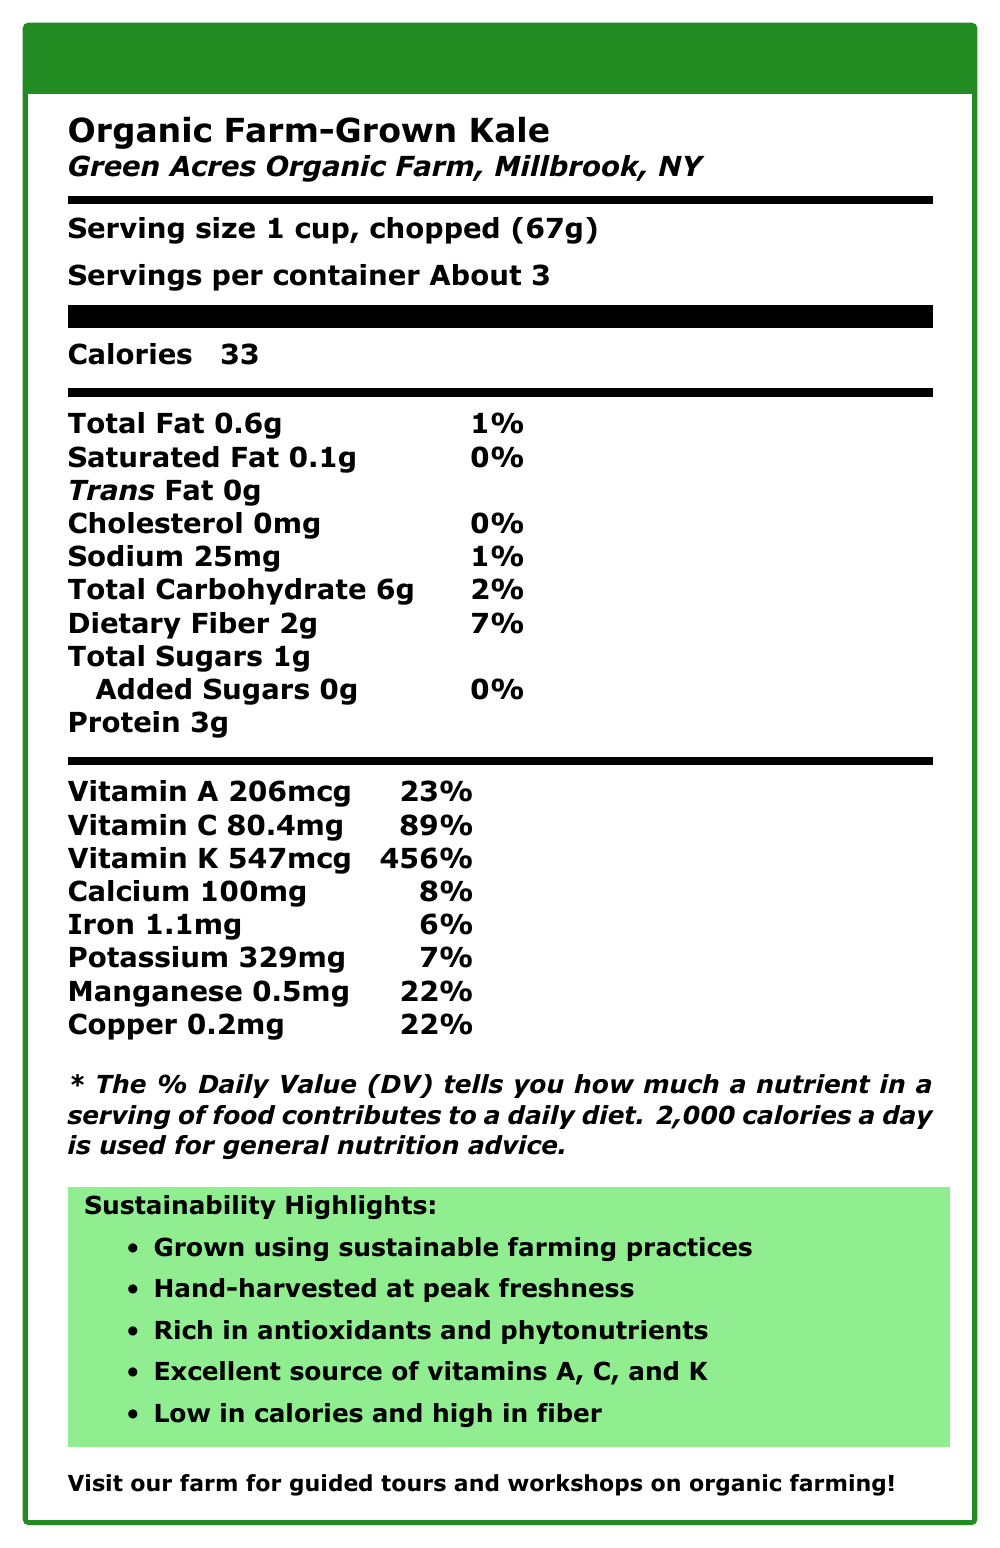what is the serving size? The serving size is clearly listed in the nutrition facts as "1 cup, chopped (67g)."
Answer: 1 cup, chopped (67g) how many calories are in one serving of organic farm-grown kale? The nutritional information states that one serving contains 33 calories.
Answer: 33 what percentage of daily vitamin C is provided by one serving? According to the nutrition label, one serving of kale provides 89% of the daily value for vitamin C.
Answer: 89% what amount of dietary fiber is in a serving? The dietary fiber content per serving is listed as 2g.
Answer: 2g which vitamin is present in the highest amount daily value percentage? Vitamin K has 547mcg, accounting for 456% of the daily value, which is the highest among the listed vitamins and minerals.
Answer: Vitamin K how much potassium is in one serving? The document lists potassium content per serving as 329mg.
Answer: 329mg how many servings are in the container? The label indicates that there are "About 3" servings per container.
Answer: About 3 how is the kale harvested at the farm? The additional info section mentions that the kale is "Hand-harvested at peak freshness."
Answer: Hand-harvested at peak freshness which mineral provides 22% of the daily value per serving? A. Calcium B. Iron C. Manganese D. Potassium The label states that manganese contributes 22% of the daily value per serving.
Answer: C what sustainability practices does Green Acres Organic Farm use? A. Solar-powered farm equipment B. Rainwater harvesting C. Biodegradable packaging D. All of the above The document mentions that the farm employs all the listed sustainability practices.
Answer: D is there any trans fat in one serving of kale? The document shows that the trans fat content per serving is 0g.
Answer: No summarize the main idea of this document. The document focuses on the health benefits of organic kale, its nutritional content, sustainable farming methods used by Green Acres Organic Farm, and additional educational and farm visitation information.
Answer: The document provides nutritional information for Organic Farm-Grown Kale, highlighting its high nutrient density with vitamins A, C, and K, and beneficial minerals. It also details Green Acres Organic Farm's sustainable farming practices and offers educational resources and farm tours. what is the daily value percentage for calcium in one serving? The document indicates that one serving provides 8% of the daily value for calcium.
Answer: 8% is cholesterol present in a serving of organic farm-grown kale? The nutrition facts state there is 0mg of cholesterol in a serving.
Answer: No what is the amount of added sugars in a serving? The document specifies that there are 0g of added sugars in one serving.
Answer: 0g how much vitamin A is in one serving? The vitamin A content for one serving is listed as 206mcg.
Answer: 206mcg what certification does Green Acres Organic Farm hold? The document mentions that the farm is USDA Organic certified.
Answer: USDA Organic what types of pests control methods are used on the farm? The farm uses natural pest management as one of its farming methods.
Answer: Natural pest management what does the label state about sustainable farming practices? The sustainability highlights section points out that the kale is "Grown using sustainable farming practices."
Answer: Grown using sustainable farming practices what type of irrigation method is used at Green Acres Organic Farm? The farming methods listed in the document include drip irrigation.
Answer: Drip irrigation does the document mention the founder of Green Acres Organic Farm? The document does not provide any information about the founder of the farm.
Answer: Cannot be determined 